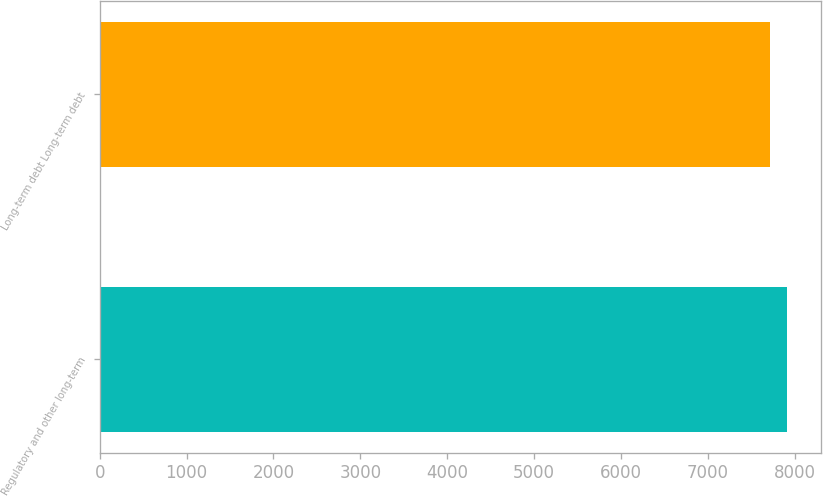Convert chart. <chart><loc_0><loc_0><loc_500><loc_500><bar_chart><fcel>Regulatory and other long-term<fcel>Long-term debt Long-term debt<nl><fcel>7909<fcel>7715<nl></chart> 